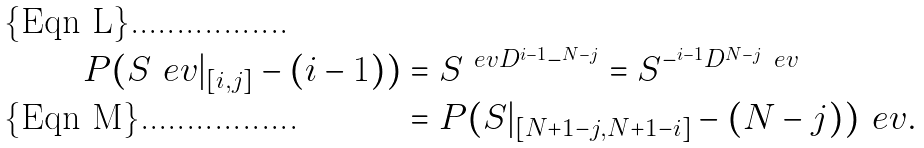<formula> <loc_0><loc_0><loc_500><loc_500>P ( S ^ { \ } e v | _ { [ i , j ] } - ( i - 1 ) ) & = S ^ { \ e v D ^ { i - 1 } - ^ { N - j } } = S ^ { - ^ { i - 1 } D ^ { N - j } \ e v } \\ & = P ( S | _ { [ N + 1 - j , N + 1 - i ] } - ( N - j ) ) ^ { \ } e v .</formula> 